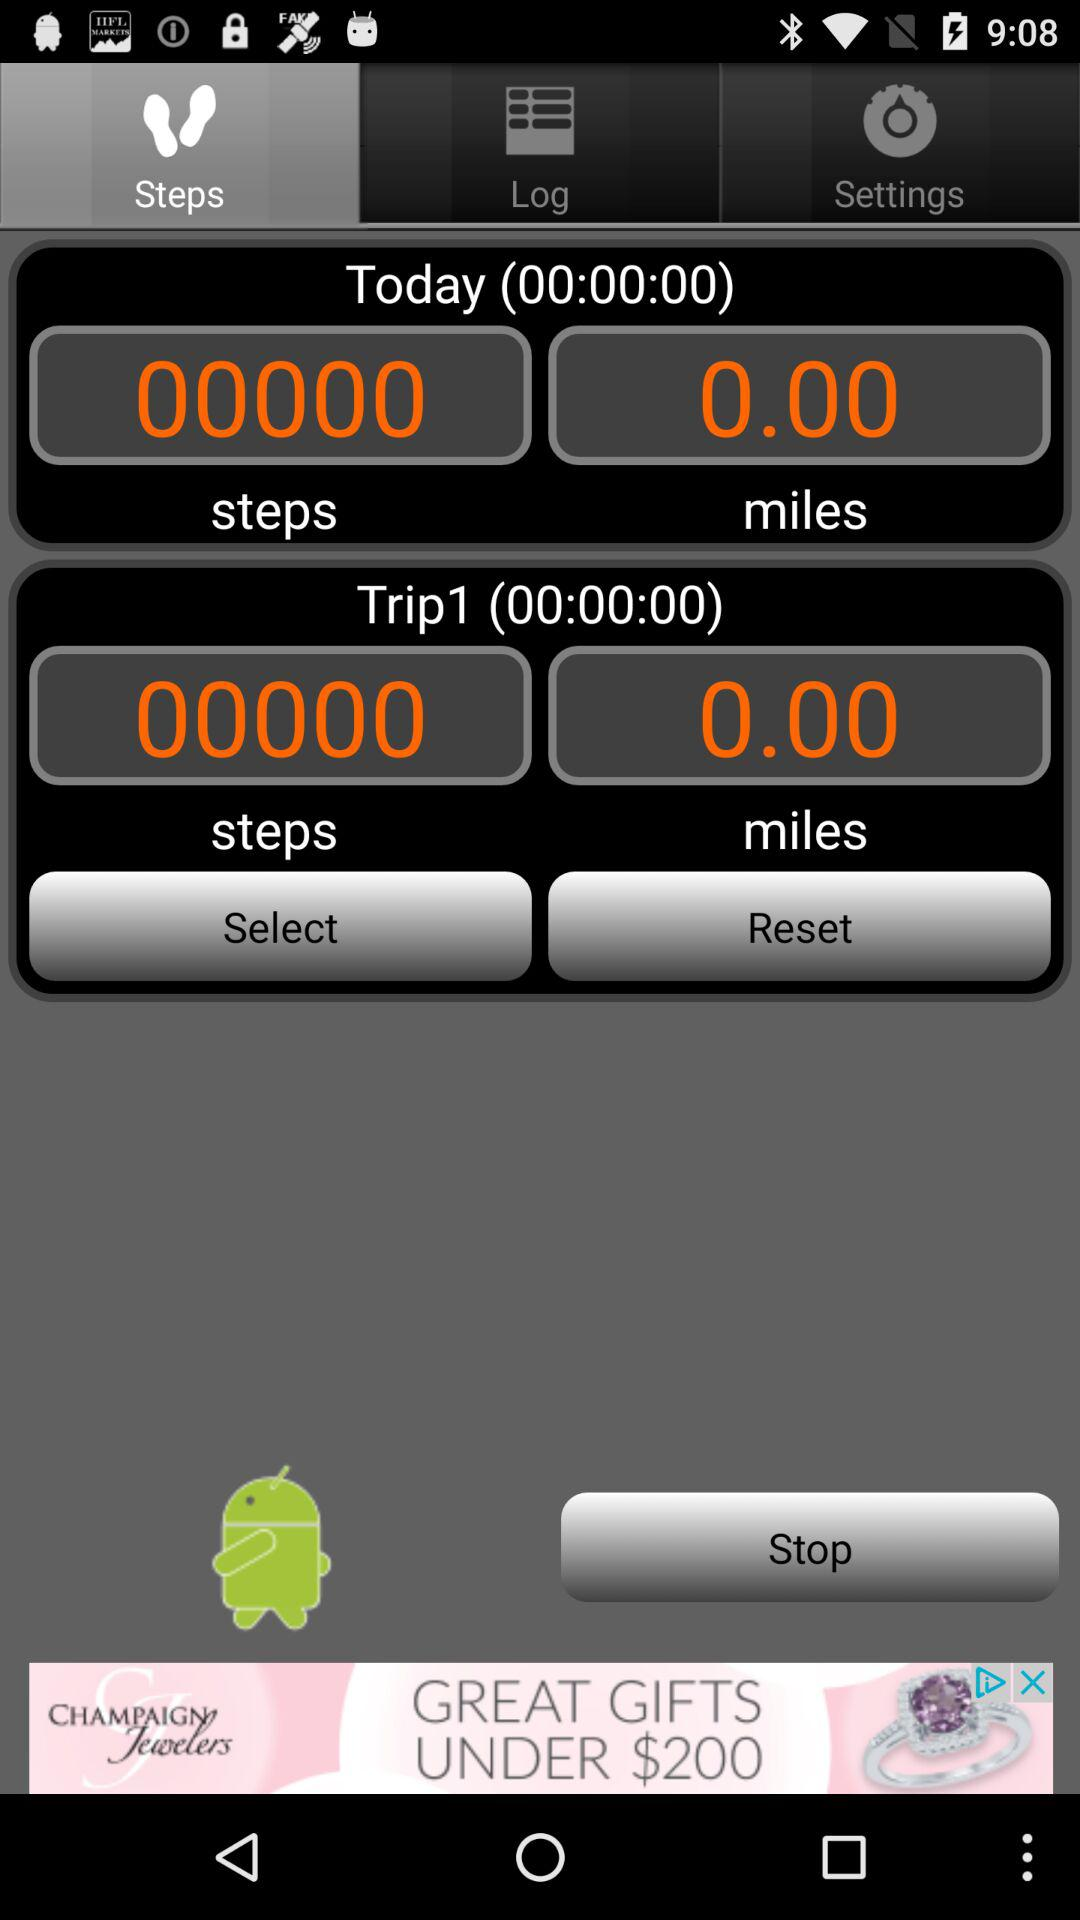What tab am I on? You are on "Steps" tab. 